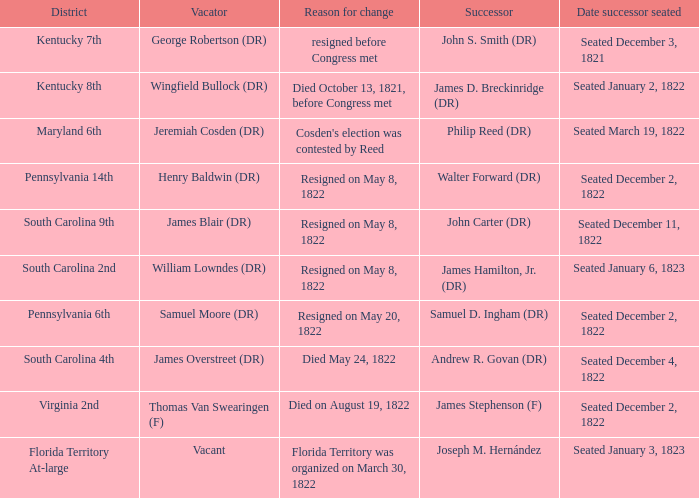Who is the successor when florida territory at-large is the district? Joseph M. Hernández. 